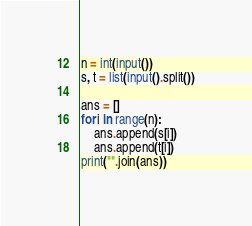<code> <loc_0><loc_0><loc_500><loc_500><_Python_>n = int(input())
s, t = list(input().split())

ans = []
for i in range(n):
    ans.append(s[i])
    ans.append(t[i])
print("".join(ans))</code> 